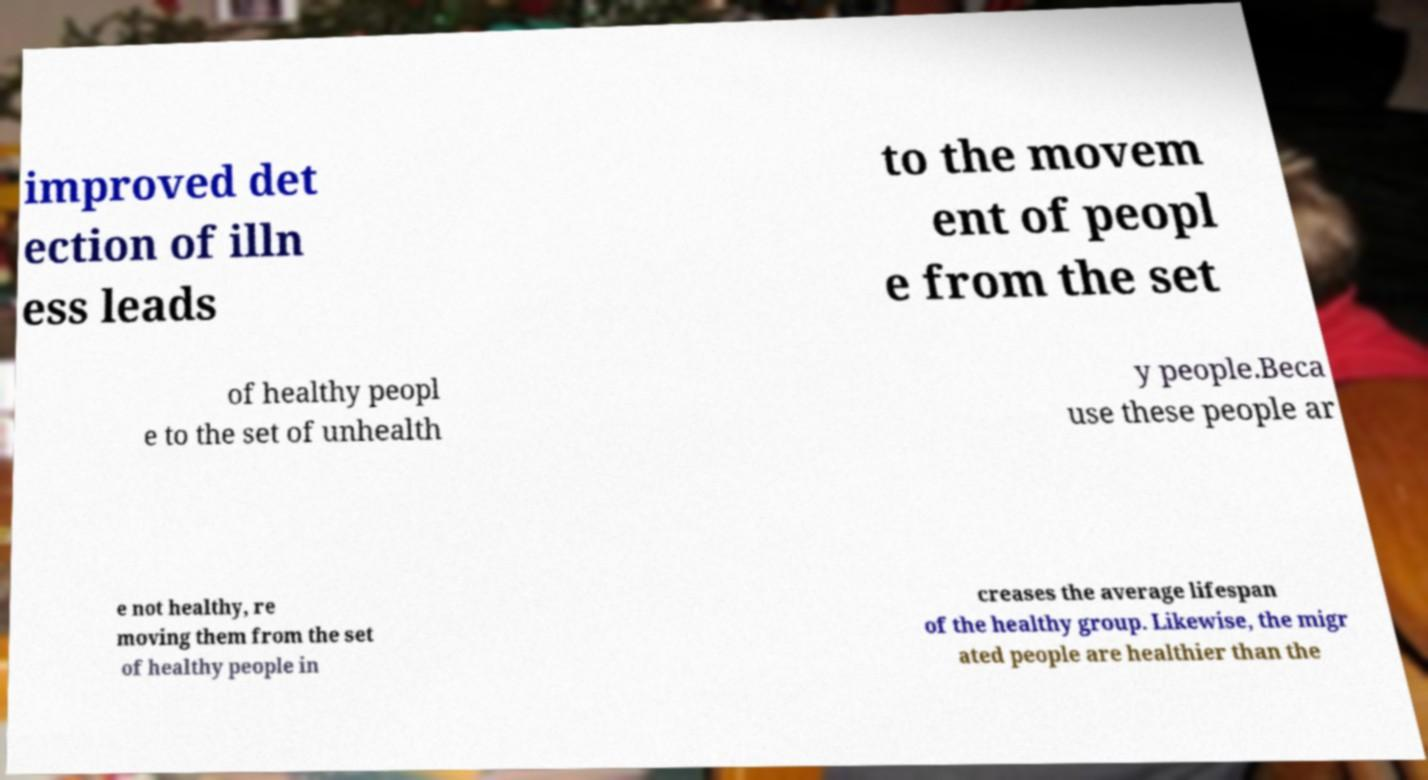Please identify and transcribe the text found in this image. improved det ection of illn ess leads to the movem ent of peopl e from the set of healthy peopl e to the set of unhealth y people.Beca use these people ar e not healthy, re moving them from the set of healthy people in creases the average lifespan of the healthy group. Likewise, the migr ated people are healthier than the 